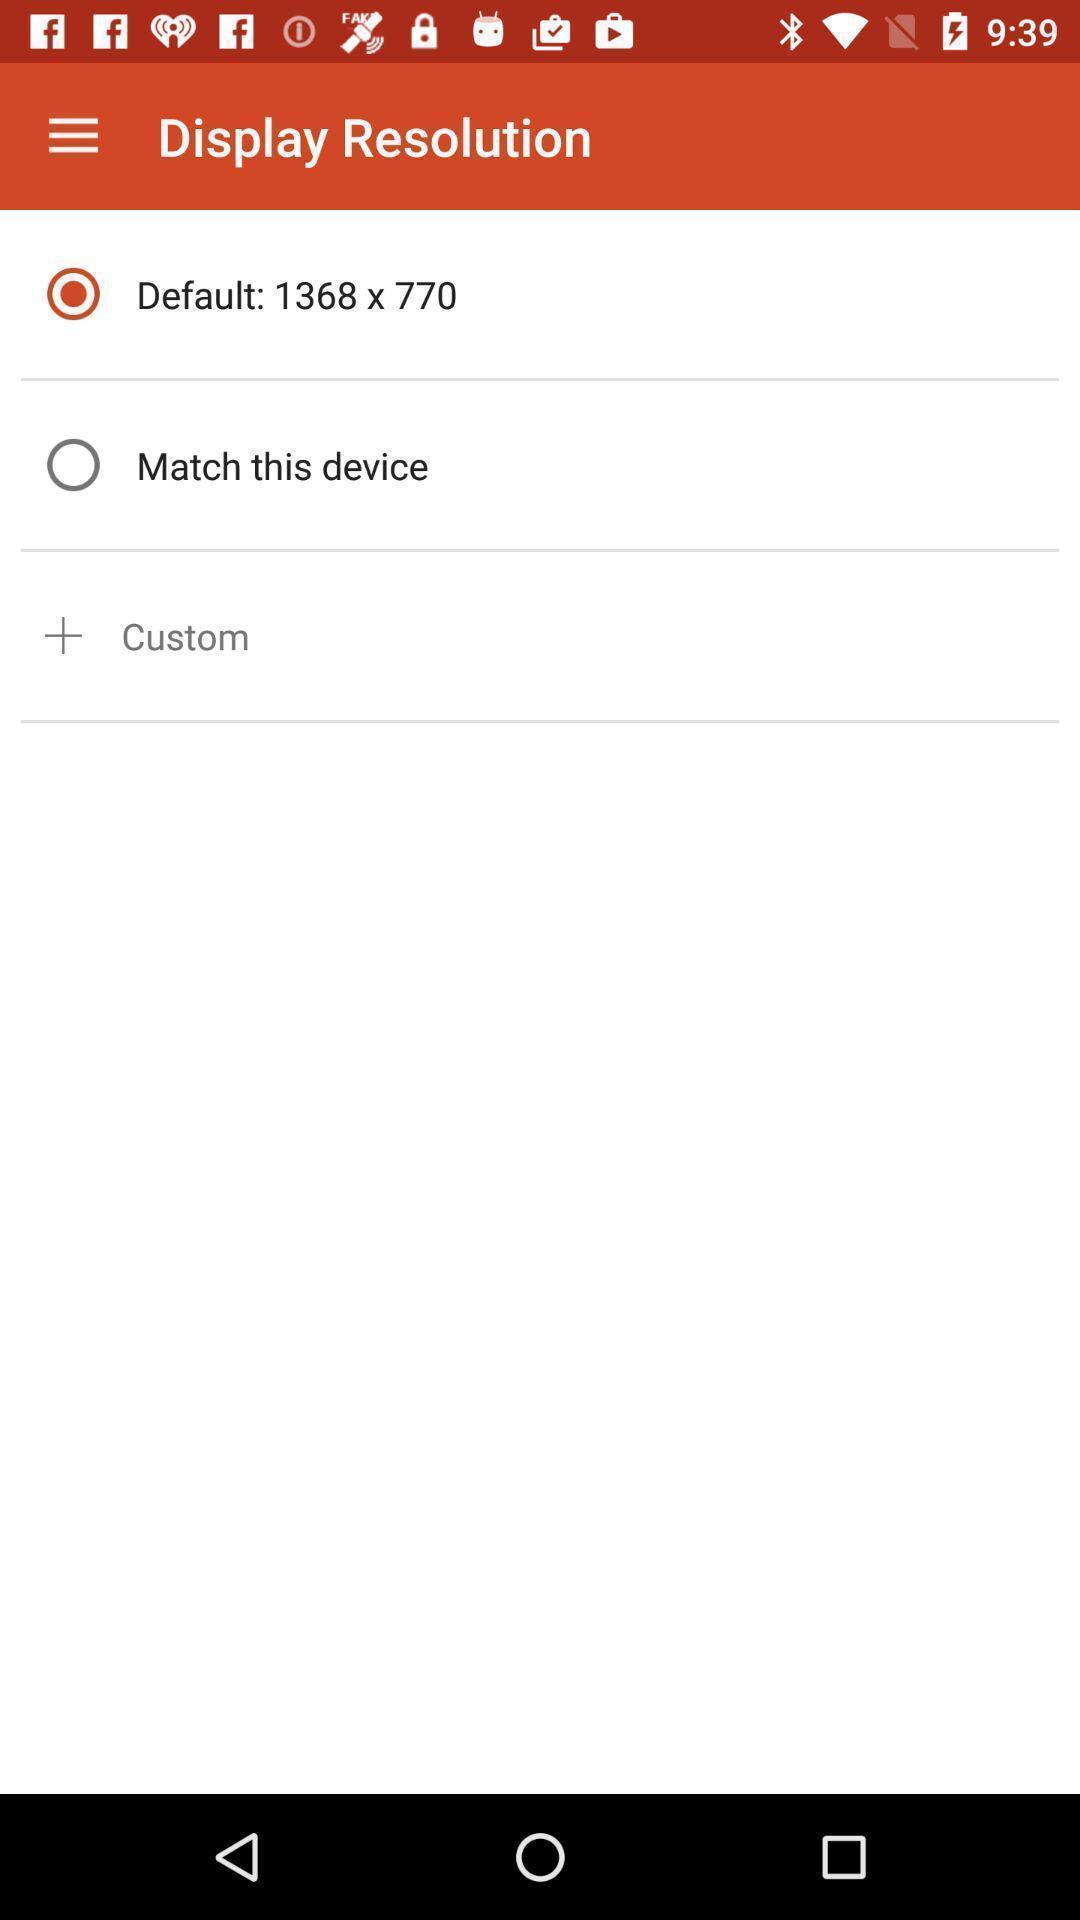Describe this image in words. Page displaying options about display resolution. 